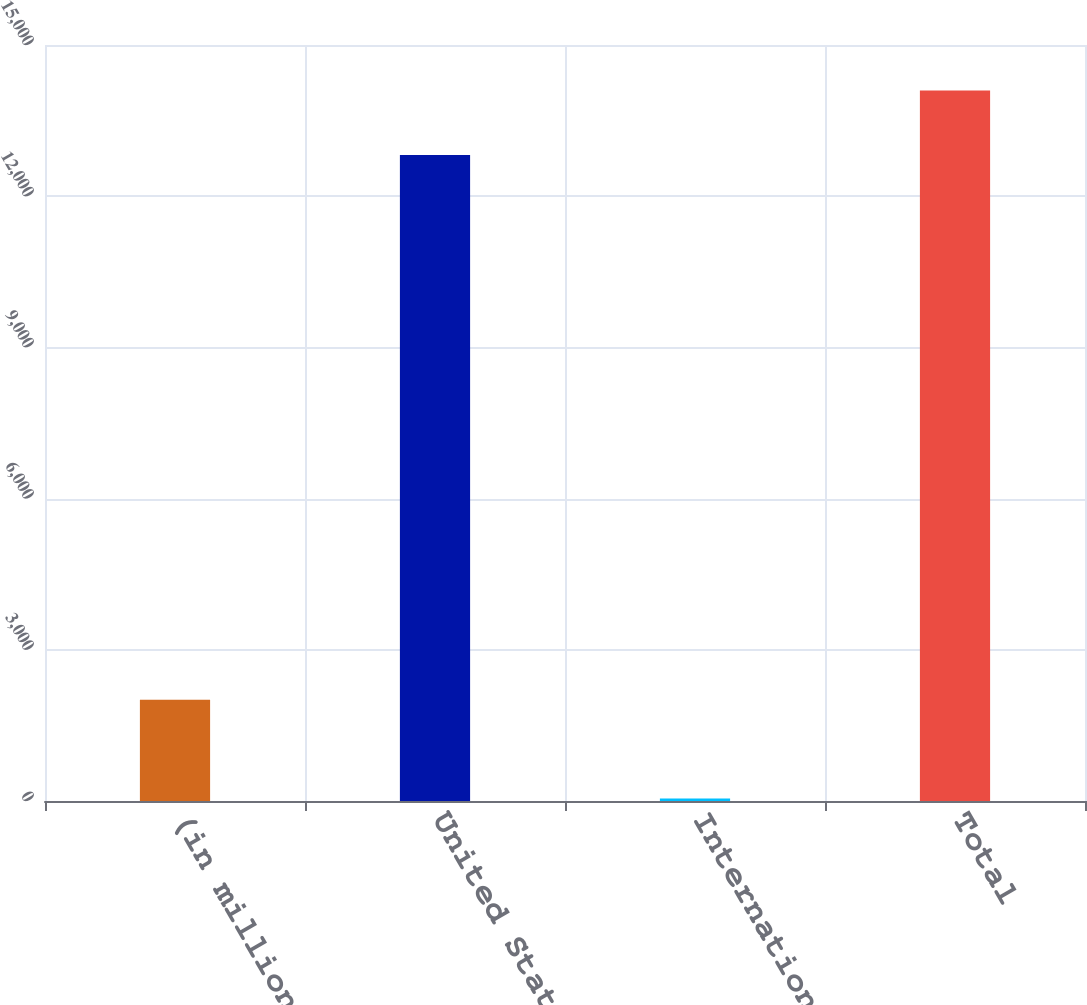Convert chart to OTSL. <chart><loc_0><loc_0><loc_500><loc_500><bar_chart><fcel>(in millions)<fcel>United States<fcel>International<fcel>Total<nl><fcel>2007<fcel>12816<fcel>52<fcel>14097.6<nl></chart> 